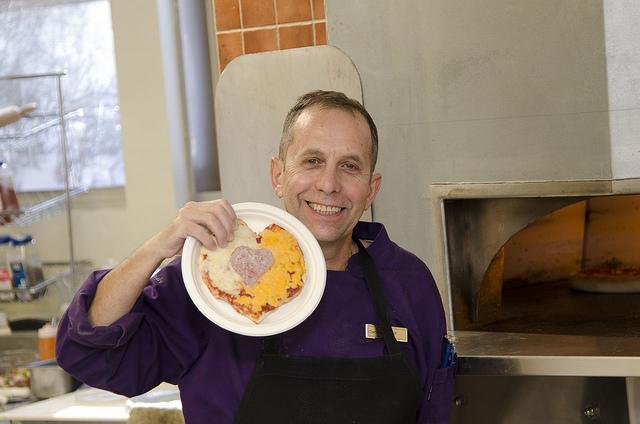What food is the heart shaped object made of?
Pick the correct solution from the four options below to address the question.
Options: Pizza, donut, spaghetti, burger. Pizza. 